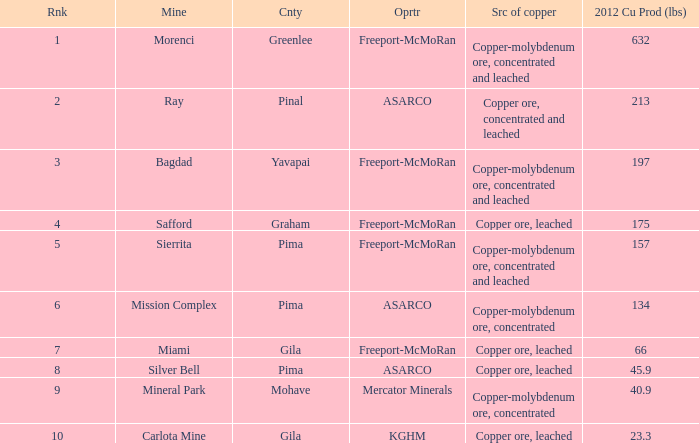What's the name of the operator who has the mission complex mine and has a 2012 Cu Production (lbs) larger than 23.3? ASARCO. 